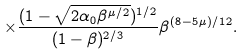Convert formula to latex. <formula><loc_0><loc_0><loc_500><loc_500>\times \frac { ( 1 - \sqrt { 2 \alpha _ { 0 } \beta ^ { \mu / 2 } } ) ^ { 1 / 2 } } { ( 1 - \beta ) ^ { 2 / 3 } } \beta ^ { ( 8 - 5 \mu ) / 1 2 } .</formula> 